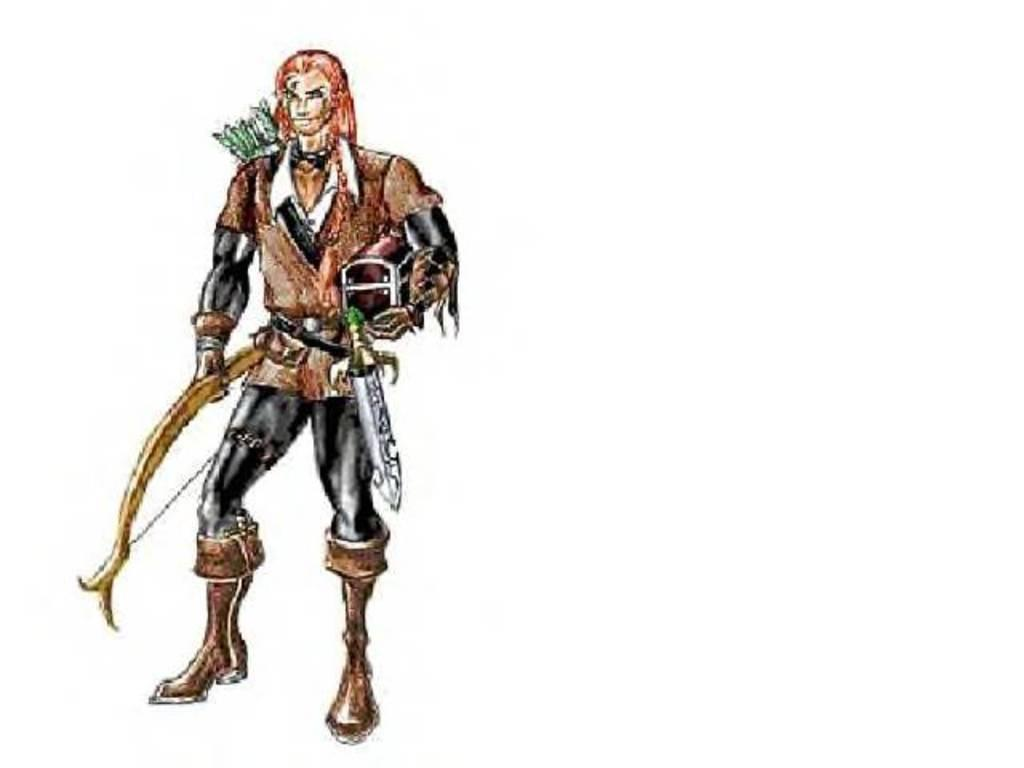What is depicted in the image? There is a drawing in the image. What is the person in the drawing doing? The person is standing in the drawing and holding a box. Are there any additional elements in the drawing? Yes, there are arrows in the drawing. What is the color of the background in the drawing? The background of the drawing is white. What type of mask is the person wearing in the drawing? There is no mask present in the drawing; the person is holding a box. How many rings are visible on the person's fingers in the drawing? There are no rings visible on the person's fingers in the drawing. 